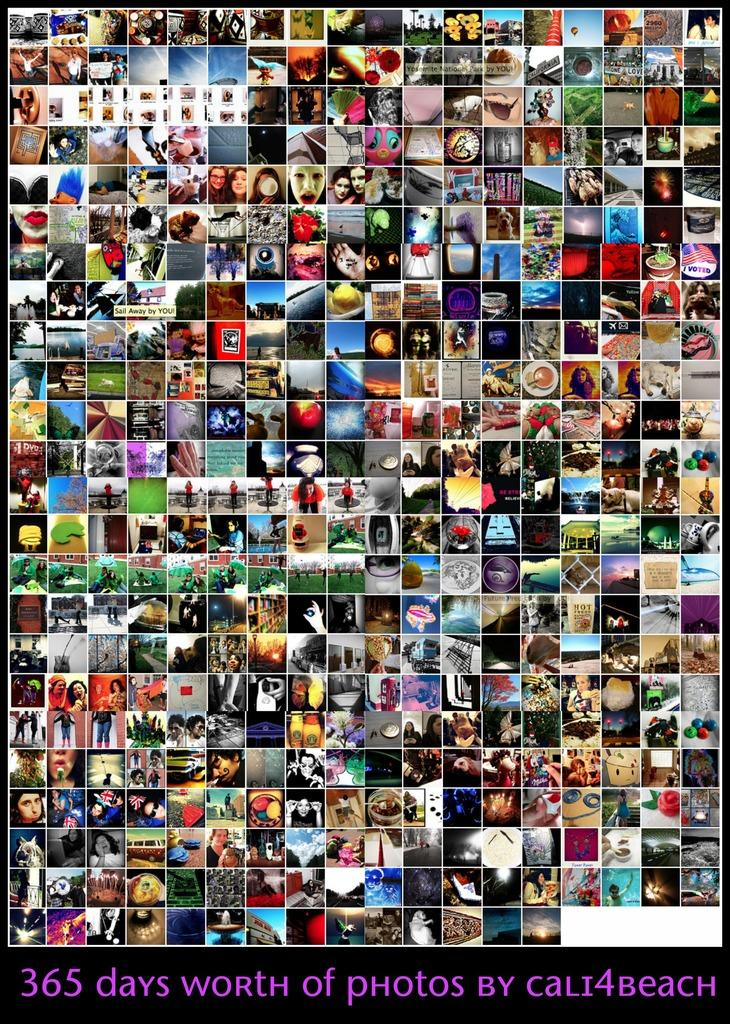What type of image is shown in the picture? The image is a photo collage. How many photos are included in the collage? There are multiple photos in the collage. Is there any text present in the image? Yes, there is text in the image. What is the color of the text in the image? The text is in purple color. Can you hear the bells ringing in the image? There are no bells present in the image, so it is not possible to hear them ringing. 